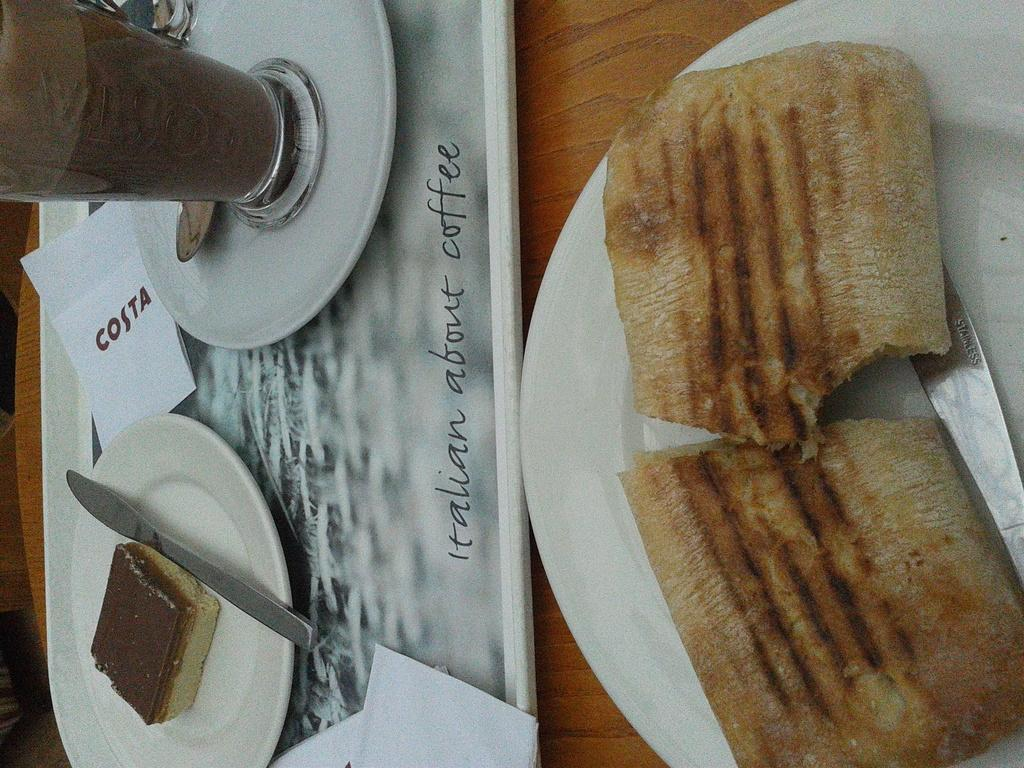What type of objects can be seen in the image? There are food items in the image. How are the food items arranged or presented? The food items are in a plate. What type of surface is the plate placed on? There is a wooden table in the image. What other object can be seen on the table? There is a glass in the image. How many women are sitting at the table with the food items in the image? There are no women present in the image; it only shows food items in a plate, a wooden table, and a glass. 